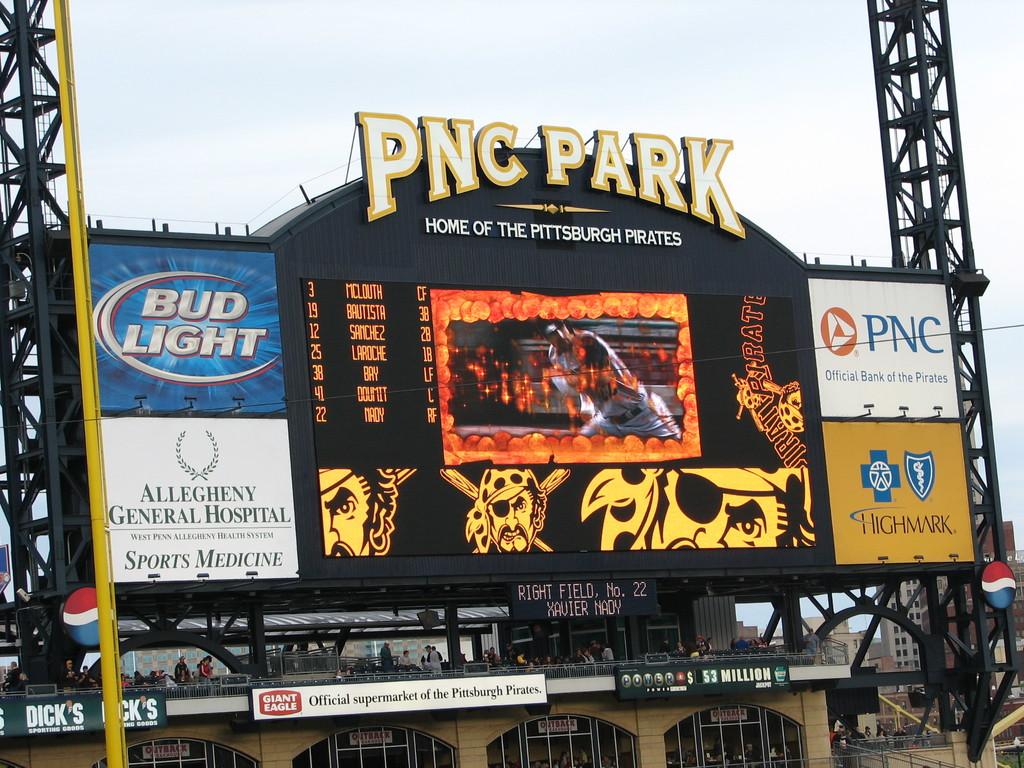What is this stadium called?
Provide a short and direct response. Pnc park. What beer brand is advertised on the sign?
Your response must be concise. Bud light. 